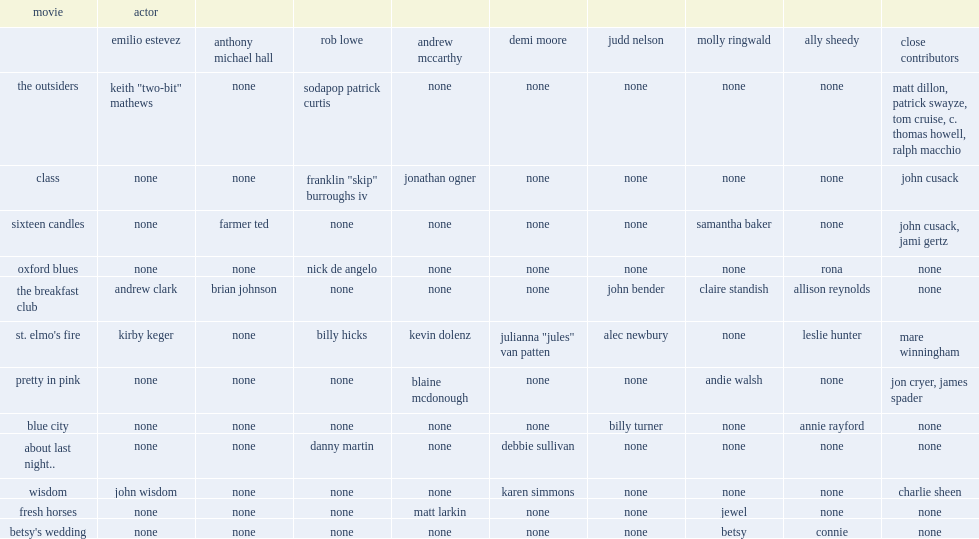Who are the members? Emilio estevez anthony michael hall rob lowe andrew mccarthy demi moore judd nelson molly ringwald ally sheedy. 